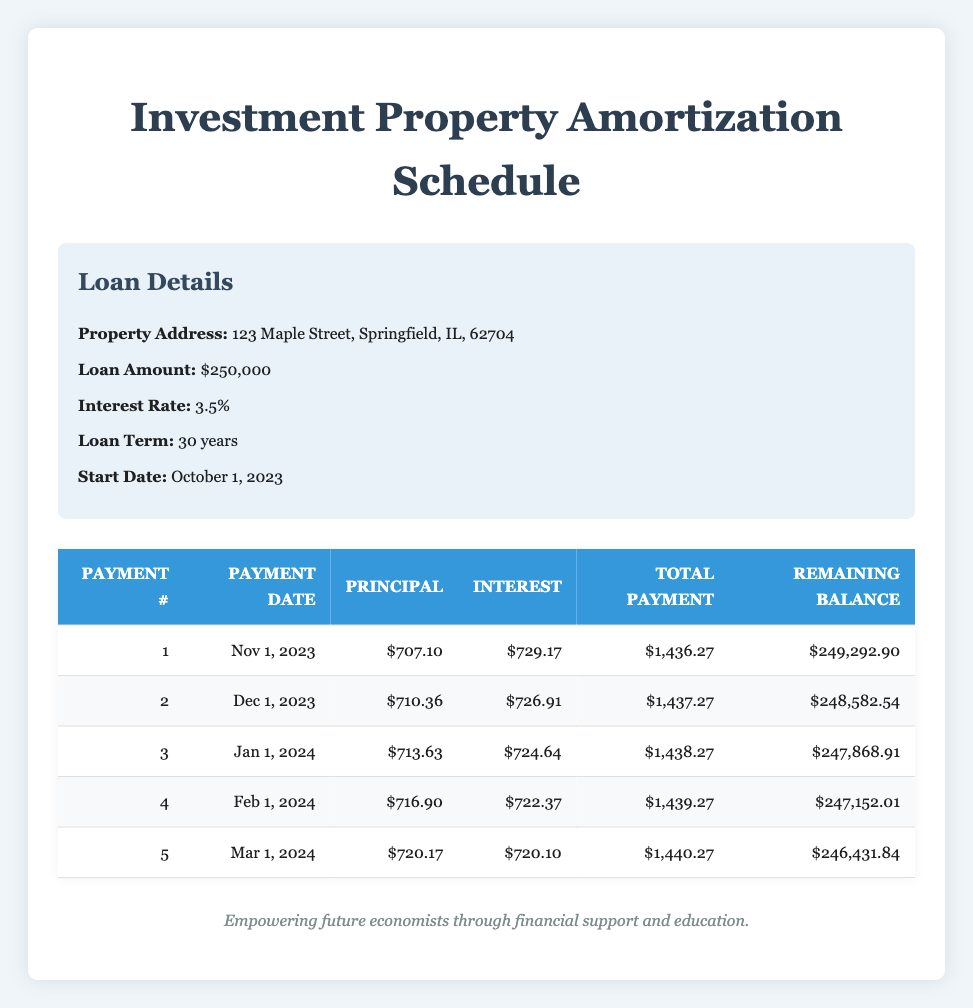What is the total payment for the first payment date? The first payment date is November 1, 2023. Referring to the table, the total payment for that date is listed as 1,436.27.
Answer: 1,436.27 What is the remaining balance after the second payment? The remaining balance after the second payment can be found in the second row, which shows the remaining balance as 248,582.54.
Answer: 248,582.54 What is the increase in principal payment from the first to the fifth payment? The principal payment for the first payment is 707.10, and for the fifth payment, it is 720.17. The increase is calculated as 720.17 - 707.10, which equals 13.07.
Answer: 13.07 Is the interest payment for the third payment greater than the interest payment for the first payment? The interest payment for the third payment is 724.64 and for the first payment, it is 729.17. Since 724.64 is less than 729.17, the answer is no.
Answer: No What is the average total payment over the first five payments? To calculate the average total payment, sum the total payments for each of the five payments: 1,436.27 + 1,437.27 + 1,438.27 + 1,439.27 + 1,440.27 = 7,091.35. Then divide by 5: 7,091.35 / 5 = 1,418.27.
Answer: 1,418.27 What is the total principal paid over the first five payments? The total principal paid is the sum of the principal payments: 707.10 + 710.36 + 713.63 + 716.90 + 720.17 = 3,068.16.
Answer: 3,068.16 What is the difference between the remaining balance after the fourth payment and the remaining balance after the second payment? The remaining balance after the fourth payment is 247,152.01, and after the second payment, it is 248,582.54. The difference is calculated as 248,582.54 - 247,152.01 = 1,430.53.
Answer: 1,430.53 Is the total payment for the second payment less than 1,440? The second payment total is 1,437.27, which is indeed less than 1,440. Therefore, the answer is yes.
Answer: Yes 